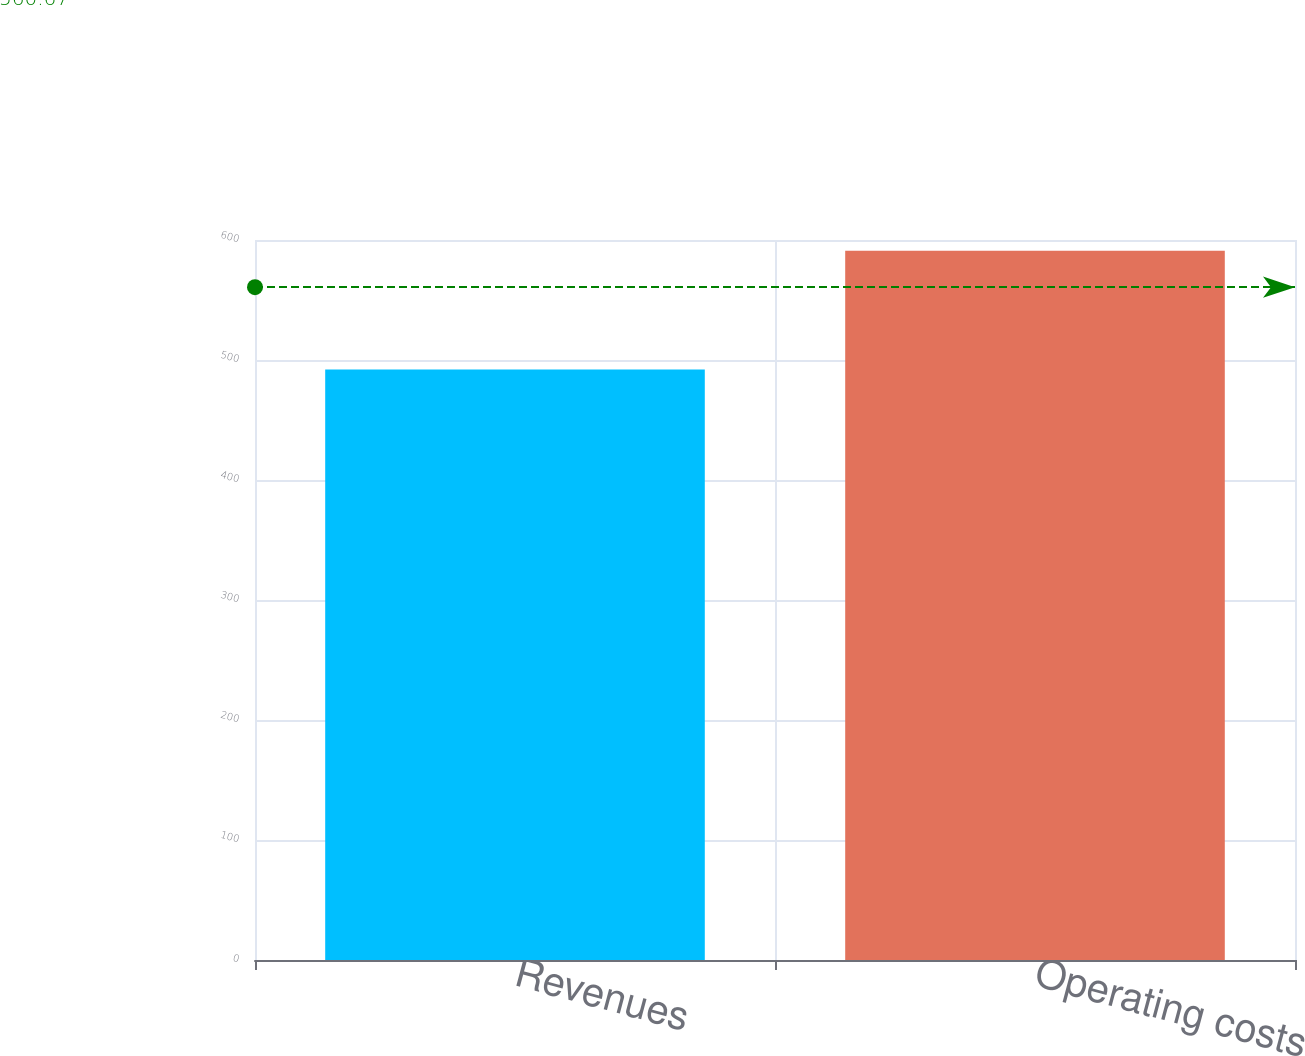Convert chart to OTSL. <chart><loc_0><loc_0><loc_500><loc_500><bar_chart><fcel>Revenues<fcel>Operating costs<nl><fcel>492<fcel>591<nl></chart> 